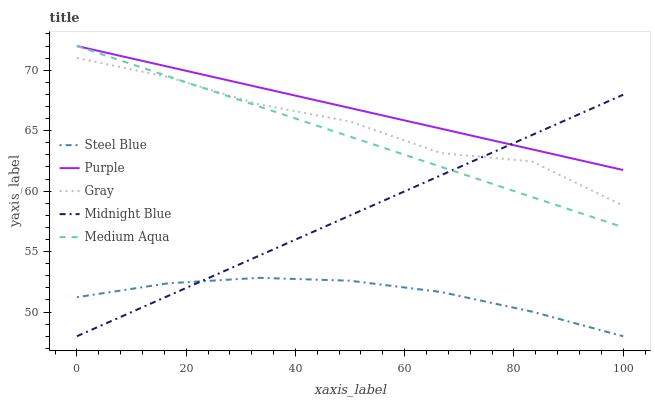Does Steel Blue have the minimum area under the curve?
Answer yes or no. Yes. Does Purple have the maximum area under the curve?
Answer yes or no. Yes. Does Gray have the minimum area under the curve?
Answer yes or no. No. Does Gray have the maximum area under the curve?
Answer yes or no. No. Is Purple the smoothest?
Answer yes or no. Yes. Is Gray the roughest?
Answer yes or no. Yes. Is Medium Aqua the smoothest?
Answer yes or no. No. Is Medium Aqua the roughest?
Answer yes or no. No. Does Steel Blue have the lowest value?
Answer yes or no. Yes. Does Gray have the lowest value?
Answer yes or no. No. Does Medium Aqua have the highest value?
Answer yes or no. Yes. Does Gray have the highest value?
Answer yes or no. No. Is Gray less than Purple?
Answer yes or no. Yes. Is Purple greater than Gray?
Answer yes or no. Yes. Does Steel Blue intersect Midnight Blue?
Answer yes or no. Yes. Is Steel Blue less than Midnight Blue?
Answer yes or no. No. Is Steel Blue greater than Midnight Blue?
Answer yes or no. No. Does Gray intersect Purple?
Answer yes or no. No. 